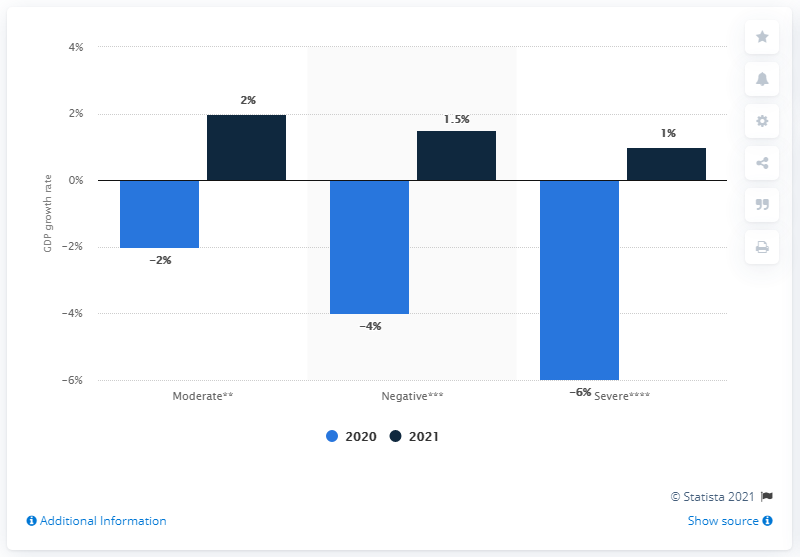Give some essential details in this illustration. The expected growth rate of GDP in 2021 if the pandemic crisis persists throughout the year is projected to be 1.5%. 